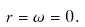<formula> <loc_0><loc_0><loc_500><loc_500>r = \omega = 0 .</formula> 